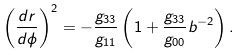Convert formula to latex. <formula><loc_0><loc_0><loc_500><loc_500>\left ( \frac { d r } { d \phi } \right ) ^ { 2 } = - \frac { g _ { 3 3 } } { g _ { 1 1 } } \left ( 1 + \frac { g _ { 3 3 } } { g _ { 0 0 } } b ^ { - 2 } \right ) .</formula> 